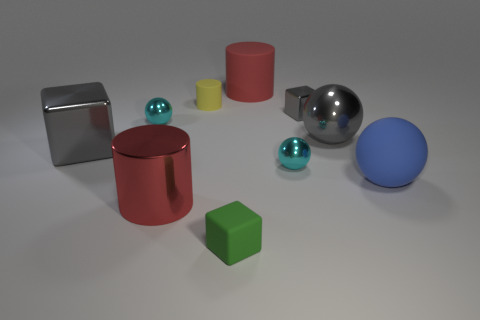Subtract all blue spheres. How many red cylinders are left? 2 Subtract all metallic balls. How many balls are left? 1 Subtract 1 blocks. How many blocks are left? 2 Subtract all brown spheres. Subtract all gray cylinders. How many spheres are left? 4 Subtract all cylinders. How many objects are left? 7 Add 6 yellow objects. How many yellow objects are left? 7 Add 3 large metallic objects. How many large metallic objects exist? 6 Subtract 0 blue blocks. How many objects are left? 10 Subtract all small metal objects. Subtract all big metal balls. How many objects are left? 6 